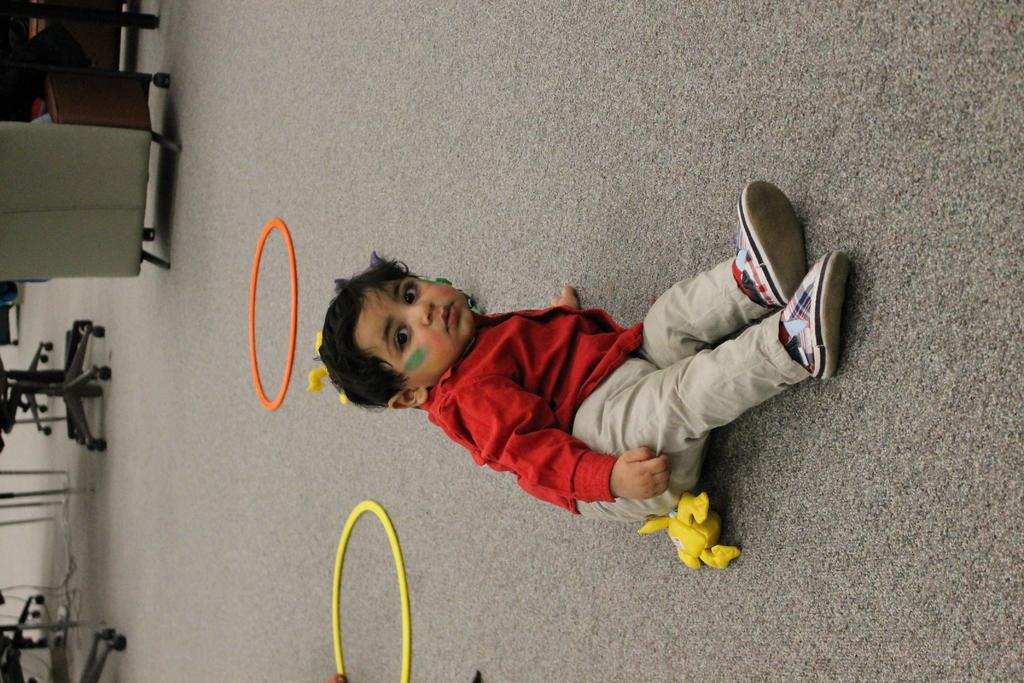What is the main subject of the image? The main subject of the image is a kid. What is the kid wearing? The kid is wearing a red shirt and cream-colored pants. What is the kid's position in the image? The kid is sitting on the ground. What can be seen on the left side of the image? There are chairs and a table on the left side of the image. What type of silk is being used to sort the pancakes in the image? There is no silk or pancakes present in the image; it features a kid sitting on the ground with chairs and a table on the left side. 